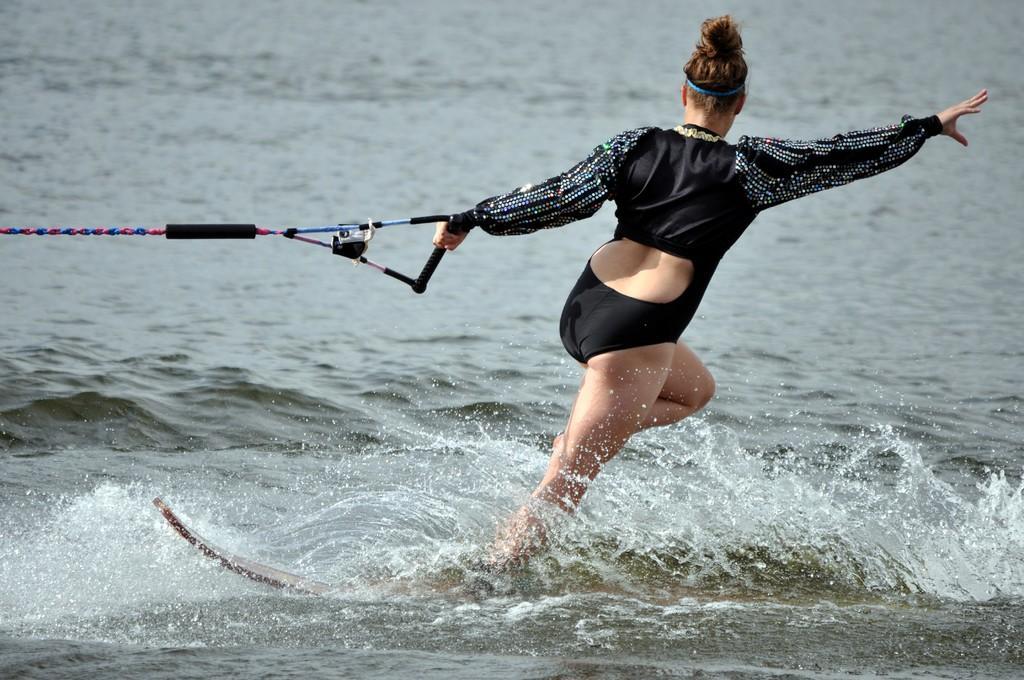Can you describe this image briefly? In this image I can see water and in it I can see a woman is standing on a board. I can see she is wearing black dress and I can see she is holding black color bar which is connected with red and blue rope. 